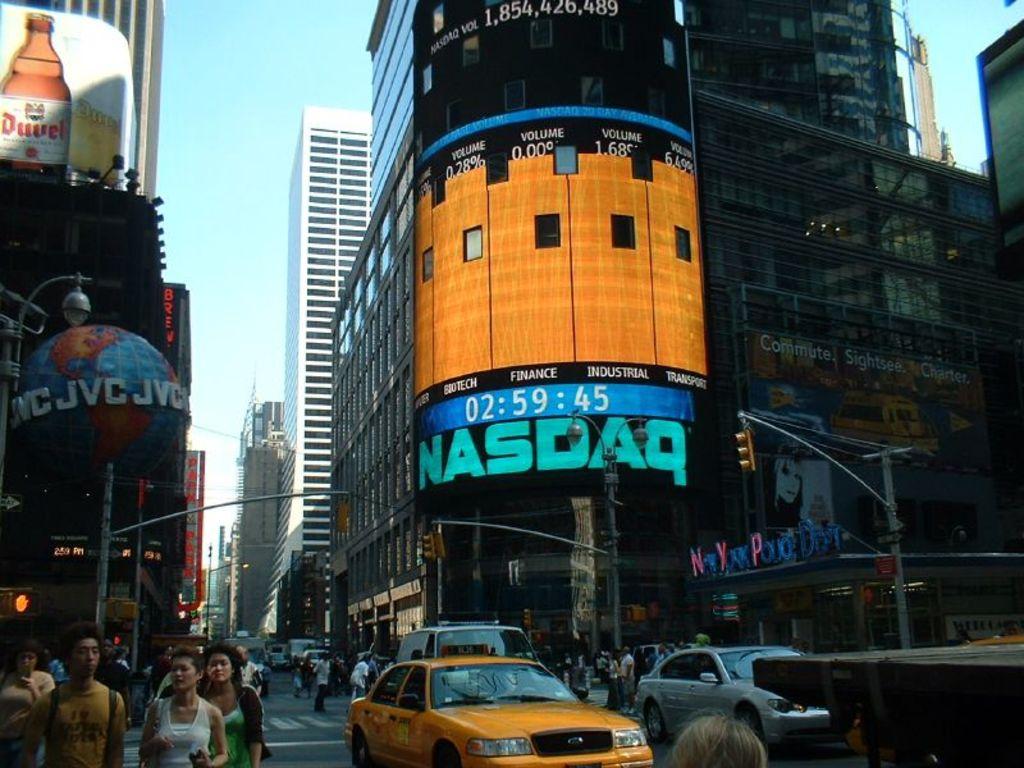What time is it?
Your response must be concise. 02:59:45. 